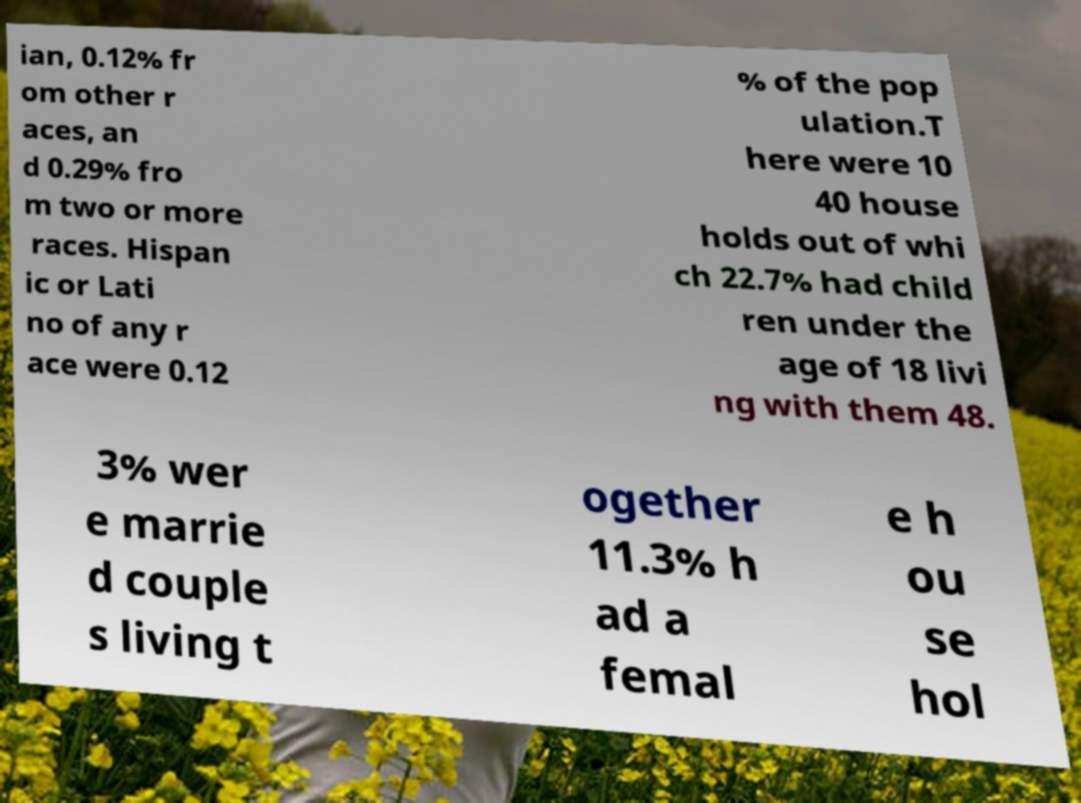Please identify and transcribe the text found in this image. ian, 0.12% fr om other r aces, an d 0.29% fro m two or more races. Hispan ic or Lati no of any r ace were 0.12 % of the pop ulation.T here were 10 40 house holds out of whi ch 22.7% had child ren under the age of 18 livi ng with them 48. 3% wer e marrie d couple s living t ogether 11.3% h ad a femal e h ou se hol 